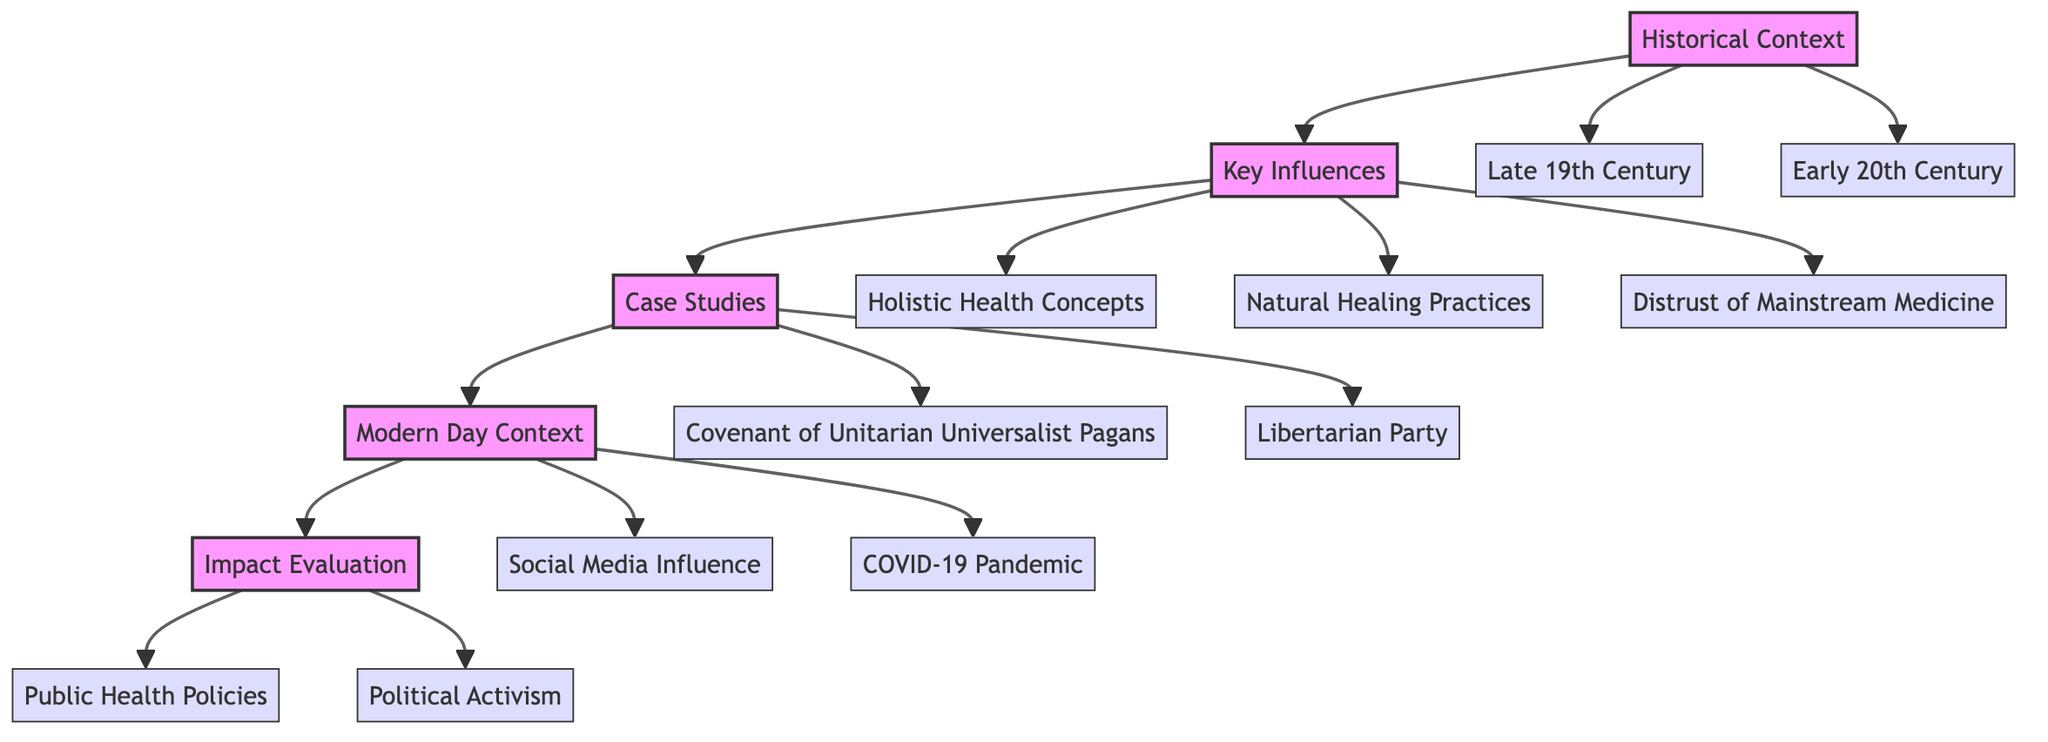What are the two timeframes mentioned in the Historical Context? The diagram lists two specific timeframes under the Historical Context: "Late 19th Century" and "Early 20th Century".
Answer: Late 19th Century, Early 20th Century How many stages are in the Clinical Pathway? The diagram contains five distinct stages which are Historical Context, Key Influences, Case Studies, Modern Day Context, and Impact Evaluation.
Answer: 5 What influences are associated with a distrust of mainstream medicine? The Key Influences stage lists "Distrust of Mainstream Medicine" and indicates that this is linked to skepticism towards governmental and scientific authorities.
Answer: Skepticism towards governmental and scientific authorities Which movement combines spirituality with alternative health practices? In the Case Studies stage, the "Covenant of Unitarian Universalist Pagans" is highlighted as an example of a movement that integrates spiritual elements with alternative health practices.
Answer: Covenant of Unitarian Universalist Pagans What are two modern factors influencing fringe political movements? The Modern Day Context stage identifies "Social Media Influence" and "COVID-19 Pandemic" as significant contemporary factors that impact fringe political movements.
Answer: Social Media Influence, COVID-19 Pandemic Explain how Key Influences relate to the Historical Context stage. The Key Influences stage is connected to the Historical Context stage, indicating that alternative medicine practices gaining traction among fringe movements in the Early 20th Century influenced the development of holistic health concepts, natural healing practices, and distrust of mainstream medicine.
Answer: They are directly connected 